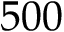Convert formula to latex. <formula><loc_0><loc_0><loc_500><loc_500>5 0 0</formula> 